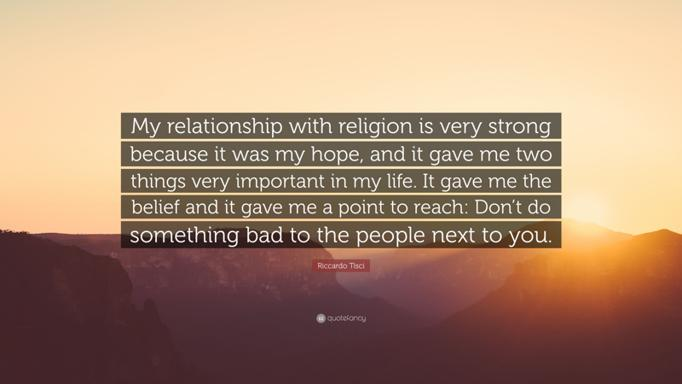How does the sunset in the background contribute to the theme of the quote? The sunset in the background symbolizes hope and the end of a day, paralleling the hope religion brings to the speaker and marking the continuous journey towards moral goals. 